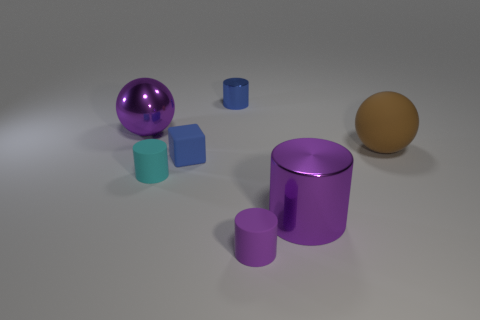The brown matte object is what size?
Your answer should be compact. Large. What is the material of the small blue cylinder?
Your answer should be compact. Metal. There is a metallic cylinder that is behind the cyan rubber object; is it the same size as the rubber cube?
Make the answer very short. Yes. How many things are tiny rubber blocks or big spheres?
Keep it short and to the point. 3. The matte object that is the same color as the big cylinder is what shape?
Offer a very short reply. Cylinder. What is the size of the metallic thing that is behind the brown object and in front of the small blue metallic object?
Offer a terse response. Large. How many matte things are there?
Your response must be concise. 4. How many spheres are red metallic things or small things?
Your answer should be compact. 0. There is a metal cylinder that is in front of the sphere right of the cyan rubber object; what number of large purple objects are on the right side of it?
Give a very brief answer. 0. The metal cylinder that is the same size as the matte cube is what color?
Offer a terse response. Blue. 